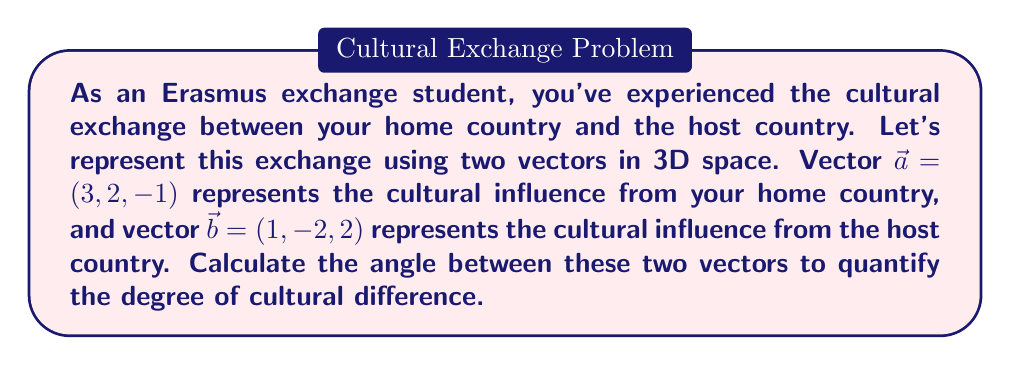Help me with this question. To find the angle between two vectors, we can use the dot product formula:

$$\cos \theta = \frac{\vec{a} \cdot \vec{b}}{|\vec{a}| |\vec{b}|}$$

Where $\theta$ is the angle between the vectors, $\vec{a} \cdot \vec{b}$ is the dot product, and $|\vec{a}|$ and $|\vec{b}|$ are the magnitudes of the vectors.

Step 1: Calculate the dot product $\vec{a} \cdot \vec{b}$
$$\vec{a} \cdot \vec{b} = (3)(1) + (2)(-2) + (-1)(2) = 3 - 4 - 2 = -3$$

Step 2: Calculate the magnitudes of $\vec{a}$ and $\vec{b}$
$$|\vec{a}| = \sqrt{3^2 + 2^2 + (-1)^2} = \sqrt{9 + 4 + 1} = \sqrt{14}$$
$$|\vec{b}| = \sqrt{1^2 + (-2)^2 + 2^2} = \sqrt{1 + 4 + 4} = 3$$

Step 3: Substitute into the formula
$$\cos \theta = \frac{-3}{\sqrt{14} \cdot 3} = \frac{-3}{3\sqrt{14}} = -\frac{1}{\sqrt{14}}$$

Step 4: Take the inverse cosine (arccos) of both sides
$$\theta = \arccos(-\frac{1}{\sqrt{14}})$$

Step 5: Calculate the result (in radians)
$$\theta \approx 1.8235 \text{ radians}$$

Step 6: Convert to degrees
$$\theta \approx 1.8235 \cdot \frac{180}{\pi} \approx 104.48°$$
Answer: The angle between the two vectors representing cultural exchange is approximately 104.48°. 